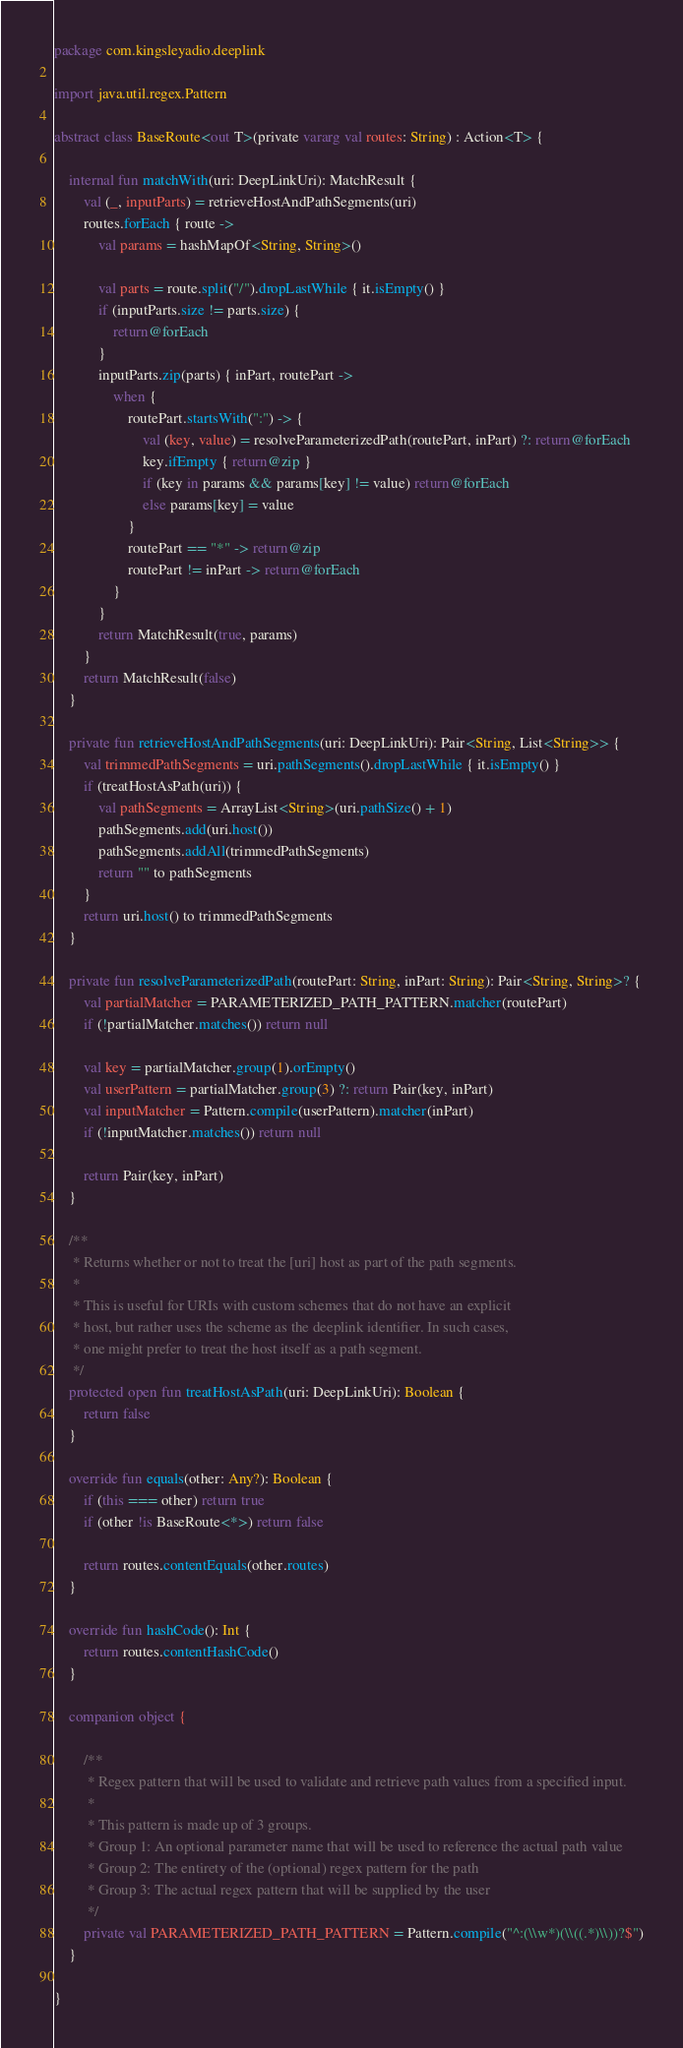<code> <loc_0><loc_0><loc_500><loc_500><_Kotlin_>package com.kingsleyadio.deeplink

import java.util.regex.Pattern

abstract class BaseRoute<out T>(private vararg val routes: String) : Action<T> {

    internal fun matchWith(uri: DeepLinkUri): MatchResult {
        val (_, inputParts) = retrieveHostAndPathSegments(uri)
        routes.forEach { route ->
            val params = hashMapOf<String, String>()

            val parts = route.split("/").dropLastWhile { it.isEmpty() }
            if (inputParts.size != parts.size) {
                return@forEach
            }
            inputParts.zip(parts) { inPart, routePart ->
                when {
                    routePart.startsWith(":") -> {
                        val (key, value) = resolveParameterizedPath(routePart, inPart) ?: return@forEach
                        key.ifEmpty { return@zip }
                        if (key in params && params[key] != value) return@forEach
                        else params[key] = value
                    }
                    routePart == "*" -> return@zip
                    routePart != inPart -> return@forEach
                }
            }
            return MatchResult(true, params)
        }
        return MatchResult(false)
    }

    private fun retrieveHostAndPathSegments(uri: DeepLinkUri): Pair<String, List<String>> {
        val trimmedPathSegments = uri.pathSegments().dropLastWhile { it.isEmpty() }
        if (treatHostAsPath(uri)) {
            val pathSegments = ArrayList<String>(uri.pathSize() + 1)
            pathSegments.add(uri.host())
            pathSegments.addAll(trimmedPathSegments)
            return "" to pathSegments
        }
        return uri.host() to trimmedPathSegments
    }

    private fun resolveParameterizedPath(routePart: String, inPart: String): Pair<String, String>? {
        val partialMatcher = PARAMETERIZED_PATH_PATTERN.matcher(routePart)
        if (!partialMatcher.matches()) return null

        val key = partialMatcher.group(1).orEmpty()
        val userPattern = partialMatcher.group(3) ?: return Pair(key, inPart)
        val inputMatcher = Pattern.compile(userPattern).matcher(inPart)
        if (!inputMatcher.matches()) return null

        return Pair(key, inPart)
    }

    /**
     * Returns whether or not to treat the [uri] host as part of the path segments.
     *
     * This is useful for URIs with custom schemes that do not have an explicit
     * host, but rather uses the scheme as the deeplink identifier. In such cases,
     * one might prefer to treat the host itself as a path segment.
     */
    protected open fun treatHostAsPath(uri: DeepLinkUri): Boolean {
        return false
    }

    override fun equals(other: Any?): Boolean {
        if (this === other) return true
        if (other !is BaseRoute<*>) return false

        return routes.contentEquals(other.routes)
    }

    override fun hashCode(): Int {
        return routes.contentHashCode()
    }

    companion object {

        /**
         * Regex pattern that will be used to validate and retrieve path values from a specified input.
         *
         * This pattern is made up of 3 groups.
         * Group 1: An optional parameter name that will be used to reference the actual path value
         * Group 2: The entirety of the (optional) regex pattern for the path
         * Group 3: The actual regex pattern that will be supplied by the user
         */
        private val PARAMETERIZED_PATH_PATTERN = Pattern.compile("^:(\\w*)(\\((.*)\\))?$")
    }

}
</code> 